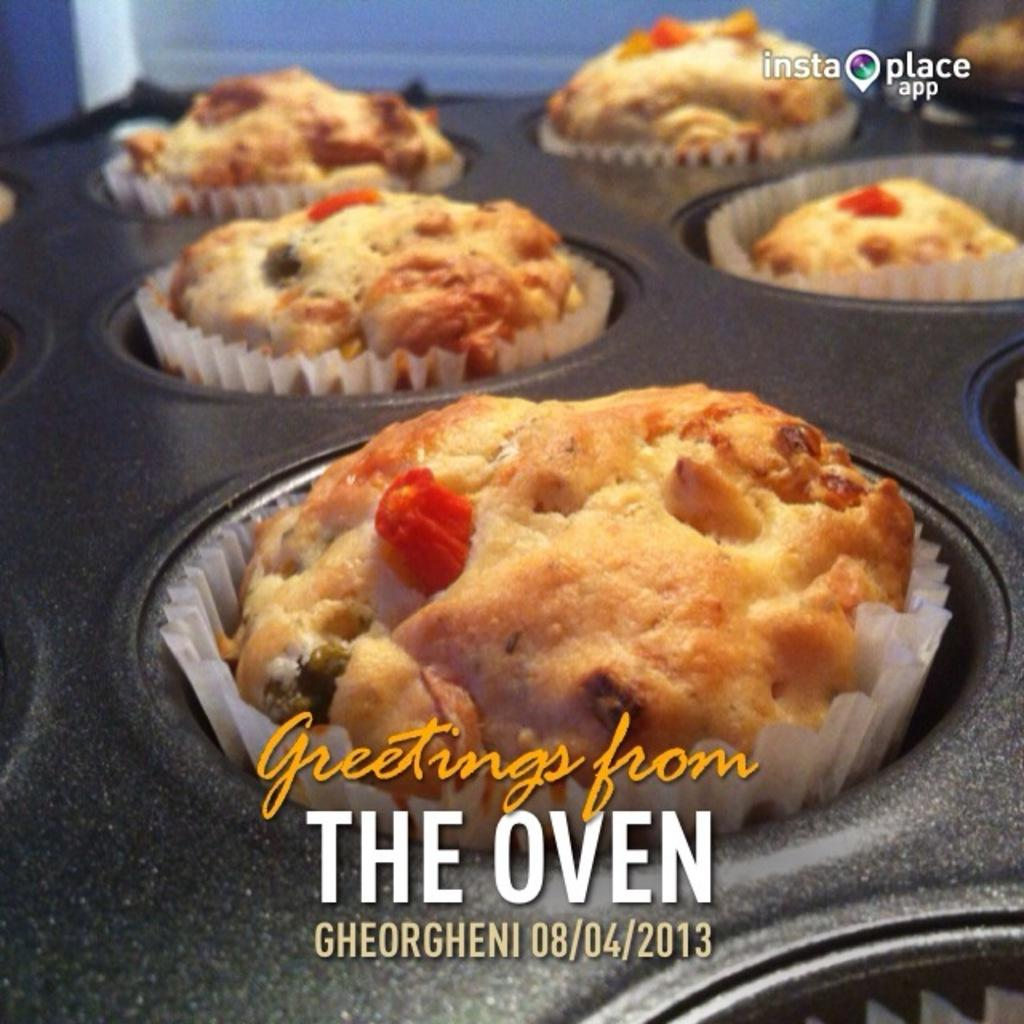What type of food is visible in the image? There are cupcakes in the image. How are the cupcakes arranged or organized in the image? The cupcakes are in a cupcake-tray. Is there any text or message on the cupcake-tray? Yes, there is writing on the cupcake-tray. How many cats can be seen sitting on the cupcakes in the image? There are no cats present in the image; it features cupcakes in a cupcake-tray with writing on it. What type of fingerprint can be seen on the cupcakes in the image? There is no fingerprint visible on the cupcakes in the image. 